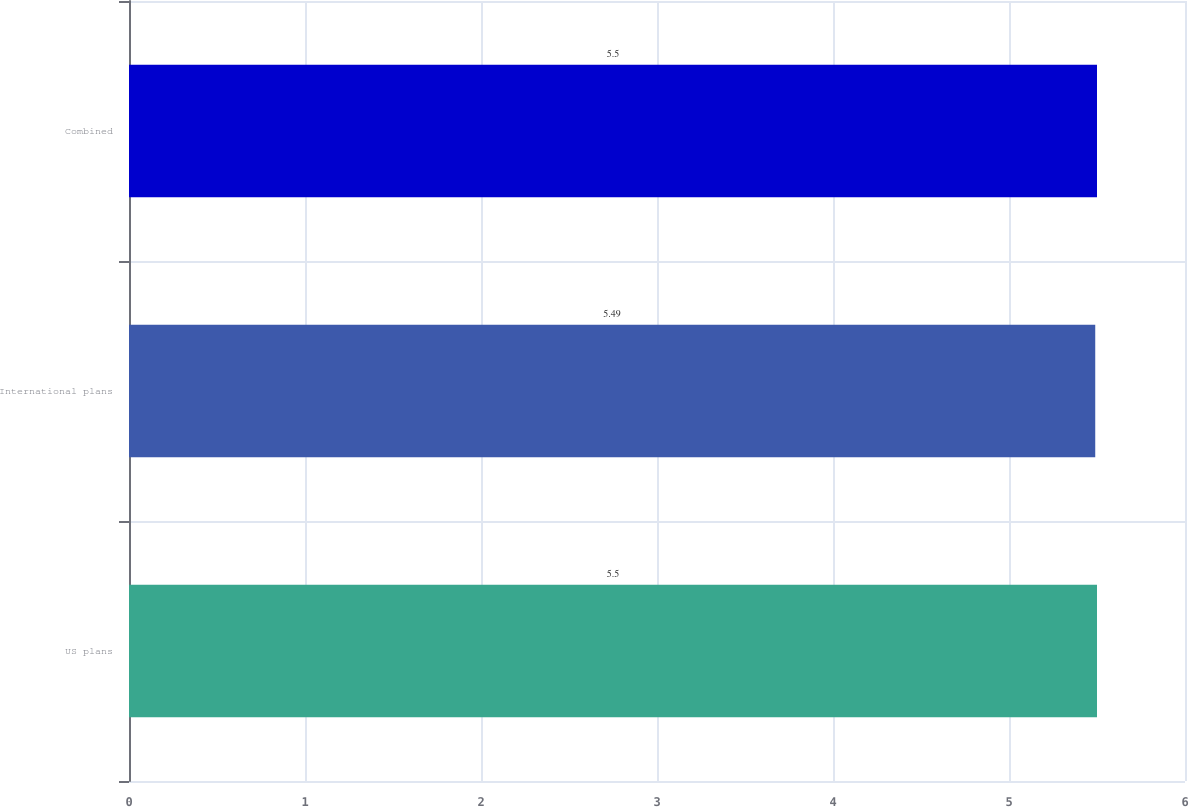Convert chart to OTSL. <chart><loc_0><loc_0><loc_500><loc_500><bar_chart><fcel>US plans<fcel>International plans<fcel>Combined<nl><fcel>5.5<fcel>5.49<fcel>5.5<nl></chart> 